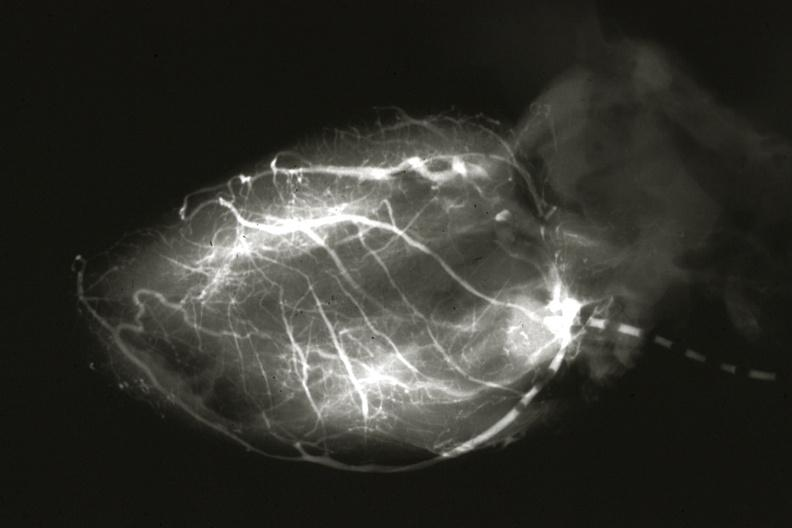s anomalous origin left from pulmonary artery?
Answer the question using a single word or phrase. Yes 